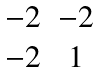Convert formula to latex. <formula><loc_0><loc_0><loc_500><loc_500>\begin{matrix} - 2 & - 2 \\ - 2 & 1 \end{matrix}</formula> 